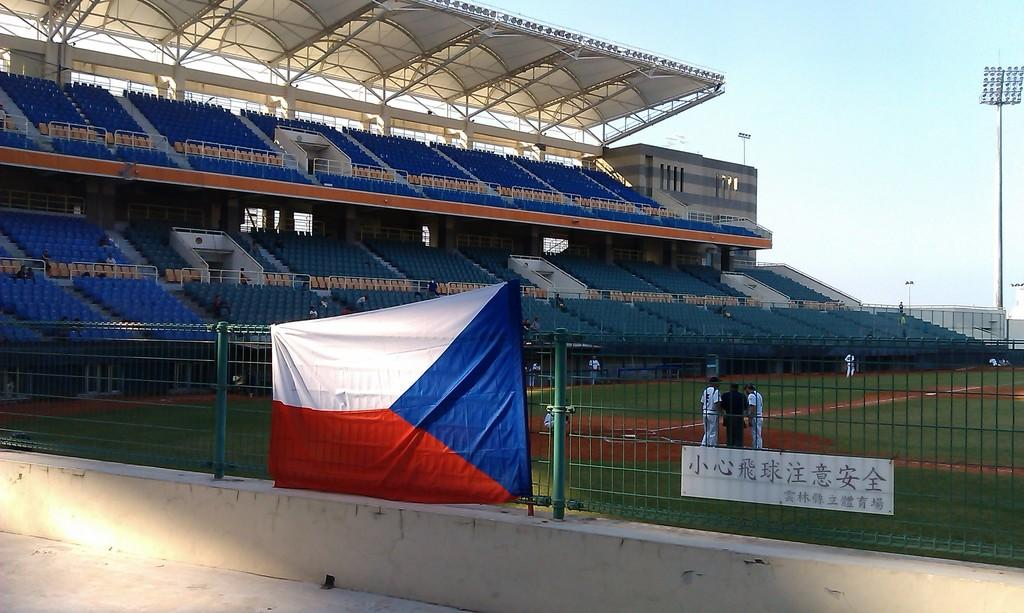Provide a one-sentence caption for the provided image. A baseball team is practicing at an empty field with Chinese characters. 